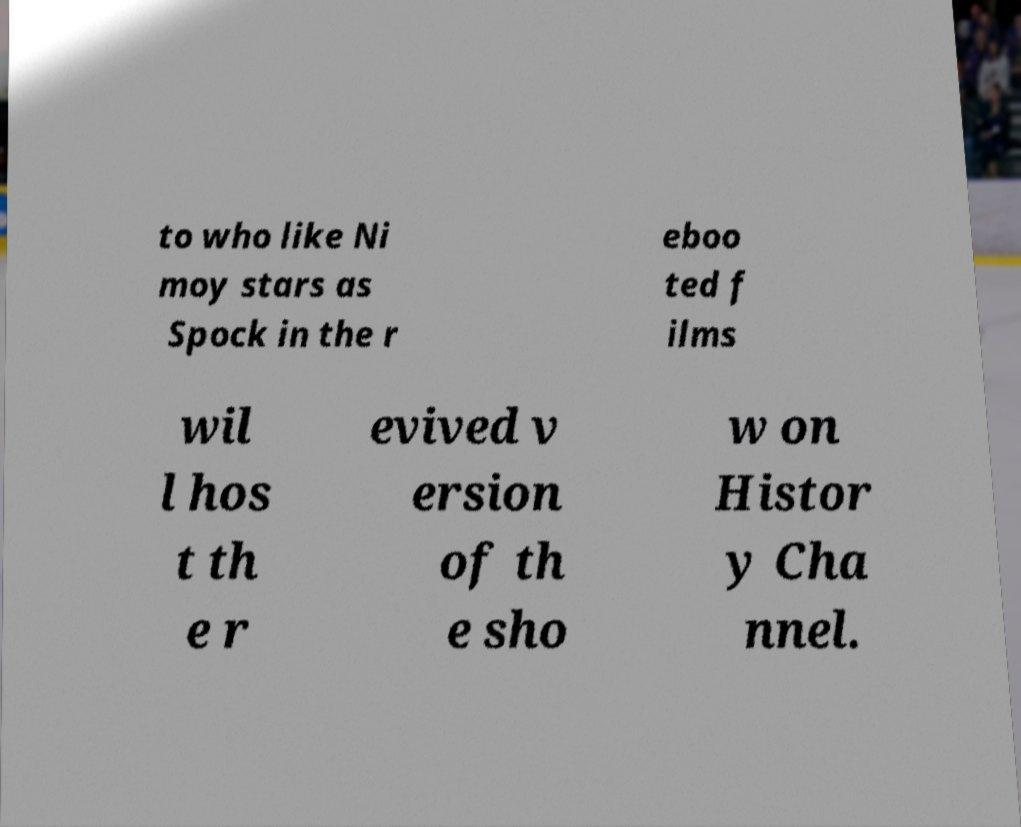I need the written content from this picture converted into text. Can you do that? to who like Ni moy stars as Spock in the r eboo ted f ilms wil l hos t th e r evived v ersion of th e sho w on Histor y Cha nnel. 